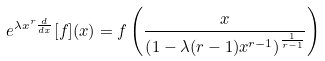<formula> <loc_0><loc_0><loc_500><loc_500>e ^ { \lambda x ^ { r } \frac { d } { d x } } [ f ] ( x ) = f \left ( \frac { x } { \left ( 1 - \lambda ( r - 1 ) x ^ { r - 1 } \right ) ^ { \frac { 1 } { r - 1 } } } \right )</formula> 